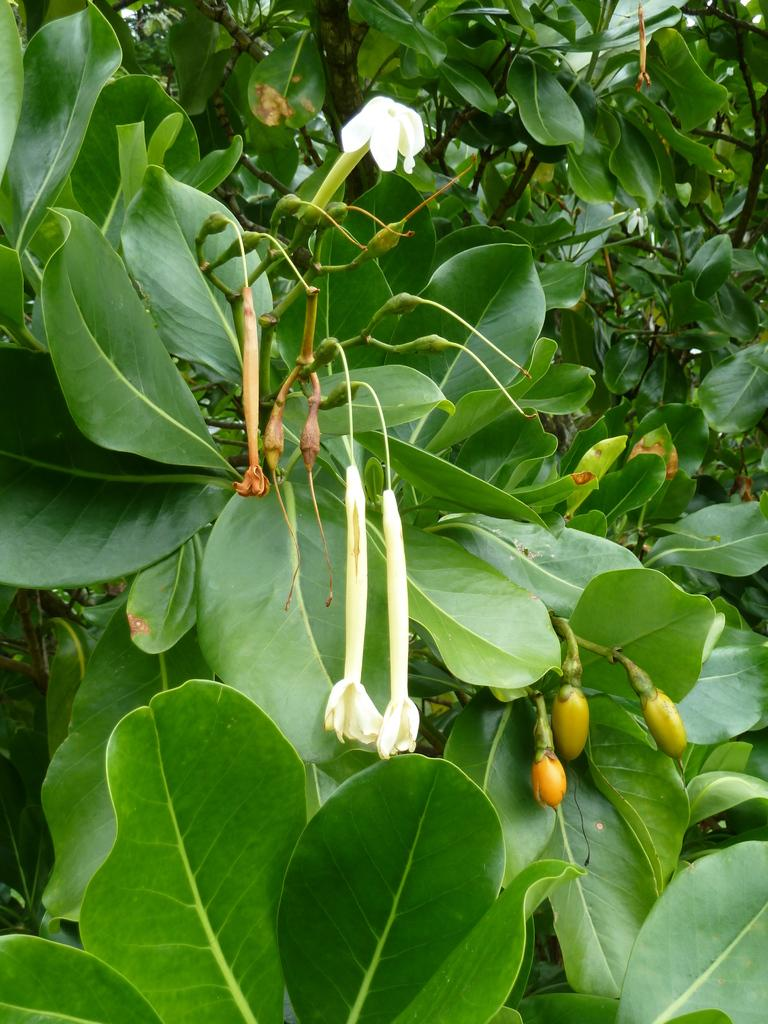What type of vegetation can be seen in the image? There are branches in the image. What can be found on the branches? The branches contain leaves, flowers, and buds. Who is the owner of the flowers in the image? There is no information about the ownership of the flowers in the image. 